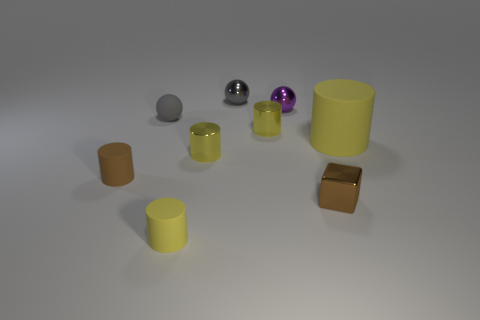Subtract all yellow cylinders. How many were subtracted if there are1yellow cylinders left? 3 Subtract all matte spheres. How many spheres are left? 2 Subtract all gray spheres. How many spheres are left? 1 Add 1 tiny shiny blocks. How many objects exist? 10 Subtract all blocks. How many objects are left? 8 Subtract 1 blocks. How many blocks are left? 0 Subtract all cyan blocks. Subtract all cyan spheres. How many blocks are left? 1 Subtract all gray cubes. How many purple balls are left? 1 Subtract all small spheres. Subtract all small yellow objects. How many objects are left? 3 Add 5 small metal cubes. How many small metal cubes are left? 6 